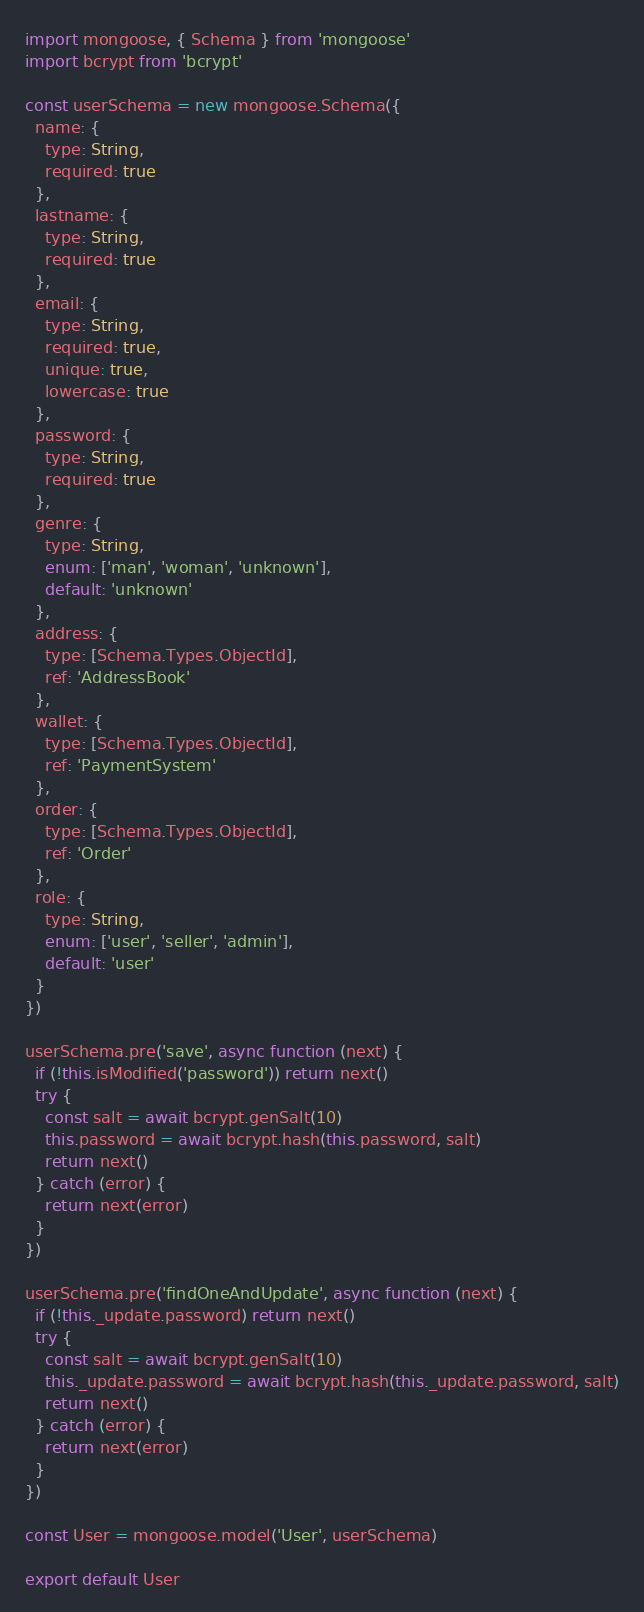Convert code to text. <code><loc_0><loc_0><loc_500><loc_500><_JavaScript_>import mongoose, { Schema } from 'mongoose'
import bcrypt from 'bcrypt'

const userSchema = new mongoose.Schema({
  name: {
    type: String,
    required: true
  },
  lastname: {
    type: String,
    required: true
  },
  email: {
    type: String,
    required: true,
    unique: true,
    lowercase: true
  },
  password: {
    type: String,
    required: true
  },
  genre: {
    type: String,
    enum: ['man', 'woman', 'unknown'],
    default: 'unknown'
  },
  address: {
    type: [Schema.Types.ObjectId],
    ref: 'AddressBook'
  },
  wallet: {
    type: [Schema.Types.ObjectId],
    ref: 'PaymentSystem'
  },
  order: {
    type: [Schema.Types.ObjectId],
    ref: 'Order'
  },
  role: {
    type: String,
    enum: ['user', 'seller', 'admin'],
    default: 'user'
  }
})

userSchema.pre('save', async function (next) {
  if (!this.isModified('password')) return next()
  try {
    const salt = await bcrypt.genSalt(10)
    this.password = await bcrypt.hash(this.password, salt)
    return next()
  } catch (error) {
    return next(error)
  }
})

userSchema.pre('findOneAndUpdate', async function (next) {
  if (!this._update.password) return next()
  try {
    const salt = await bcrypt.genSalt(10)
    this._update.password = await bcrypt.hash(this._update.password, salt)
    return next()
  } catch (error) {
    return next(error)
  }
})

const User = mongoose.model('User', userSchema)

export default User
</code> 